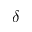Convert formula to latex. <formula><loc_0><loc_0><loc_500><loc_500>\delta</formula> 